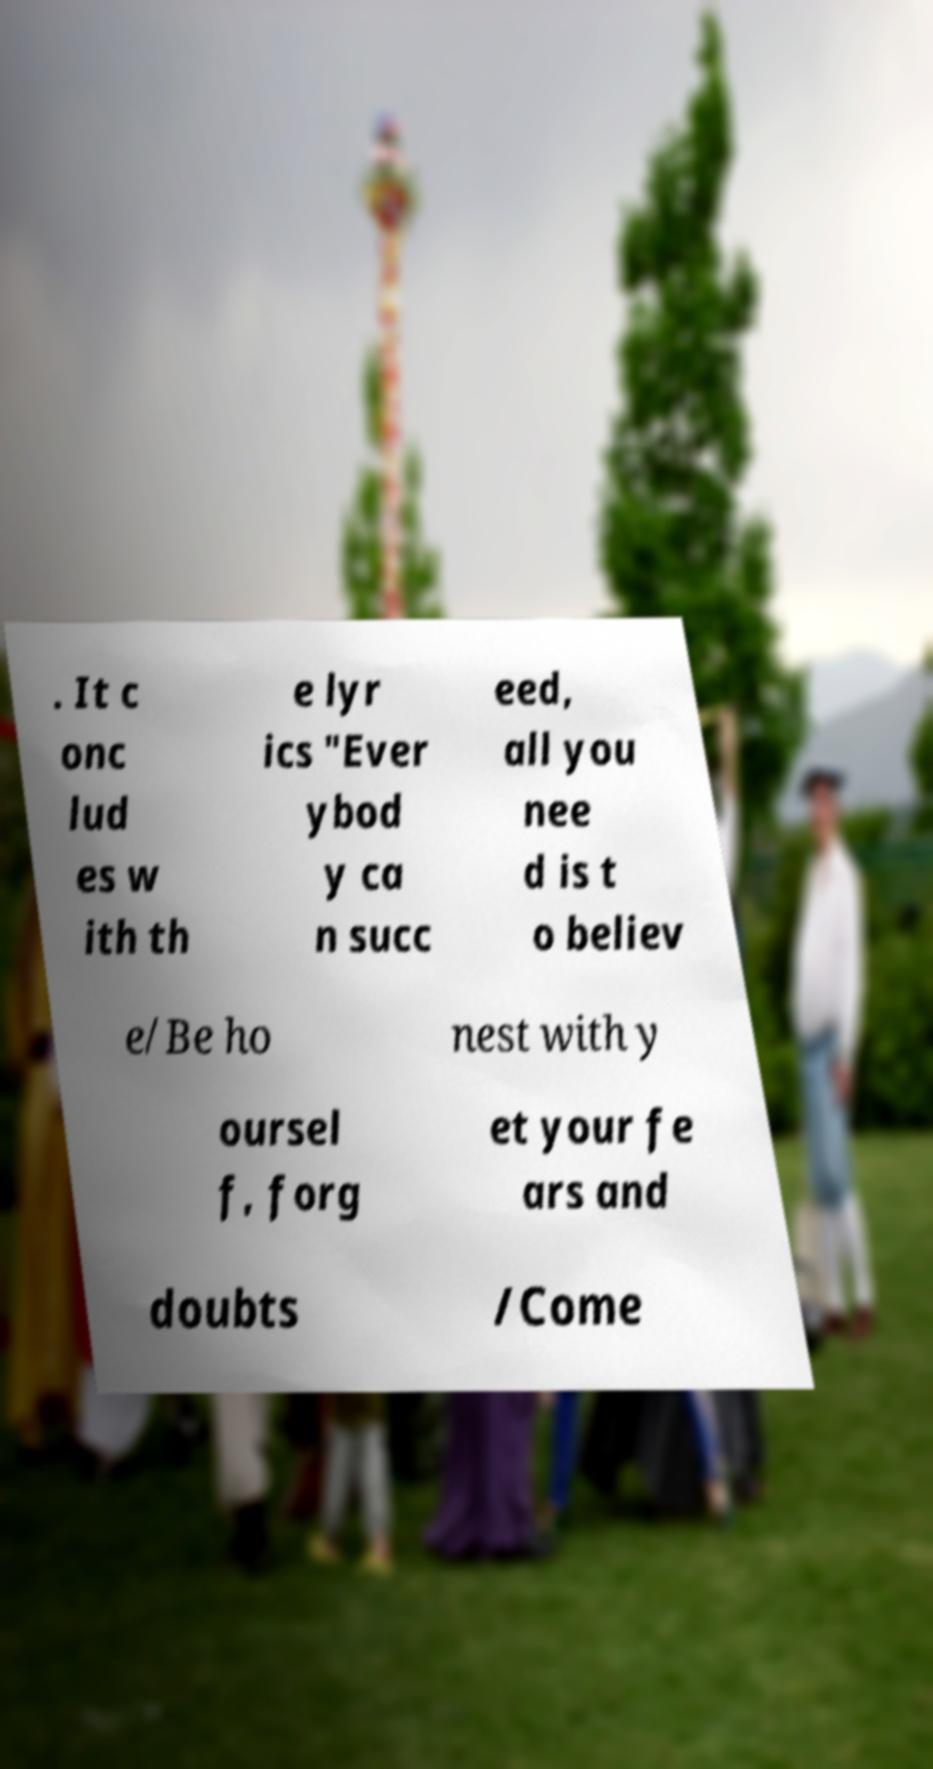Can you read and provide the text displayed in the image?This photo seems to have some interesting text. Can you extract and type it out for me? . It c onc lud es w ith th e lyr ics "Ever ybod y ca n succ eed, all you nee d is t o believ e/Be ho nest with y oursel f, forg et your fe ars and doubts /Come 